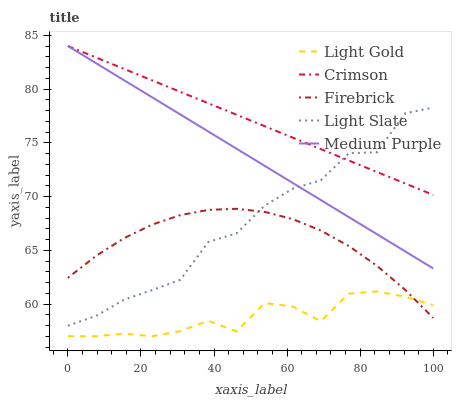Does Light Gold have the minimum area under the curve?
Answer yes or no. Yes. Does Crimson have the maximum area under the curve?
Answer yes or no. Yes. Does Light Slate have the minimum area under the curve?
Answer yes or no. No. Does Light Slate have the maximum area under the curve?
Answer yes or no. No. Is Crimson the smoothest?
Answer yes or no. Yes. Is Light Slate the roughest?
Answer yes or no. Yes. Is Firebrick the smoothest?
Answer yes or no. No. Is Firebrick the roughest?
Answer yes or no. No. Does Light Gold have the lowest value?
Answer yes or no. Yes. Does Light Slate have the lowest value?
Answer yes or no. No. Does Medium Purple have the highest value?
Answer yes or no. Yes. Does Light Slate have the highest value?
Answer yes or no. No. Is Light Gold less than Crimson?
Answer yes or no. Yes. Is Crimson greater than Light Gold?
Answer yes or no. Yes. Does Firebrick intersect Light Gold?
Answer yes or no. Yes. Is Firebrick less than Light Gold?
Answer yes or no. No. Is Firebrick greater than Light Gold?
Answer yes or no. No. Does Light Gold intersect Crimson?
Answer yes or no. No. 